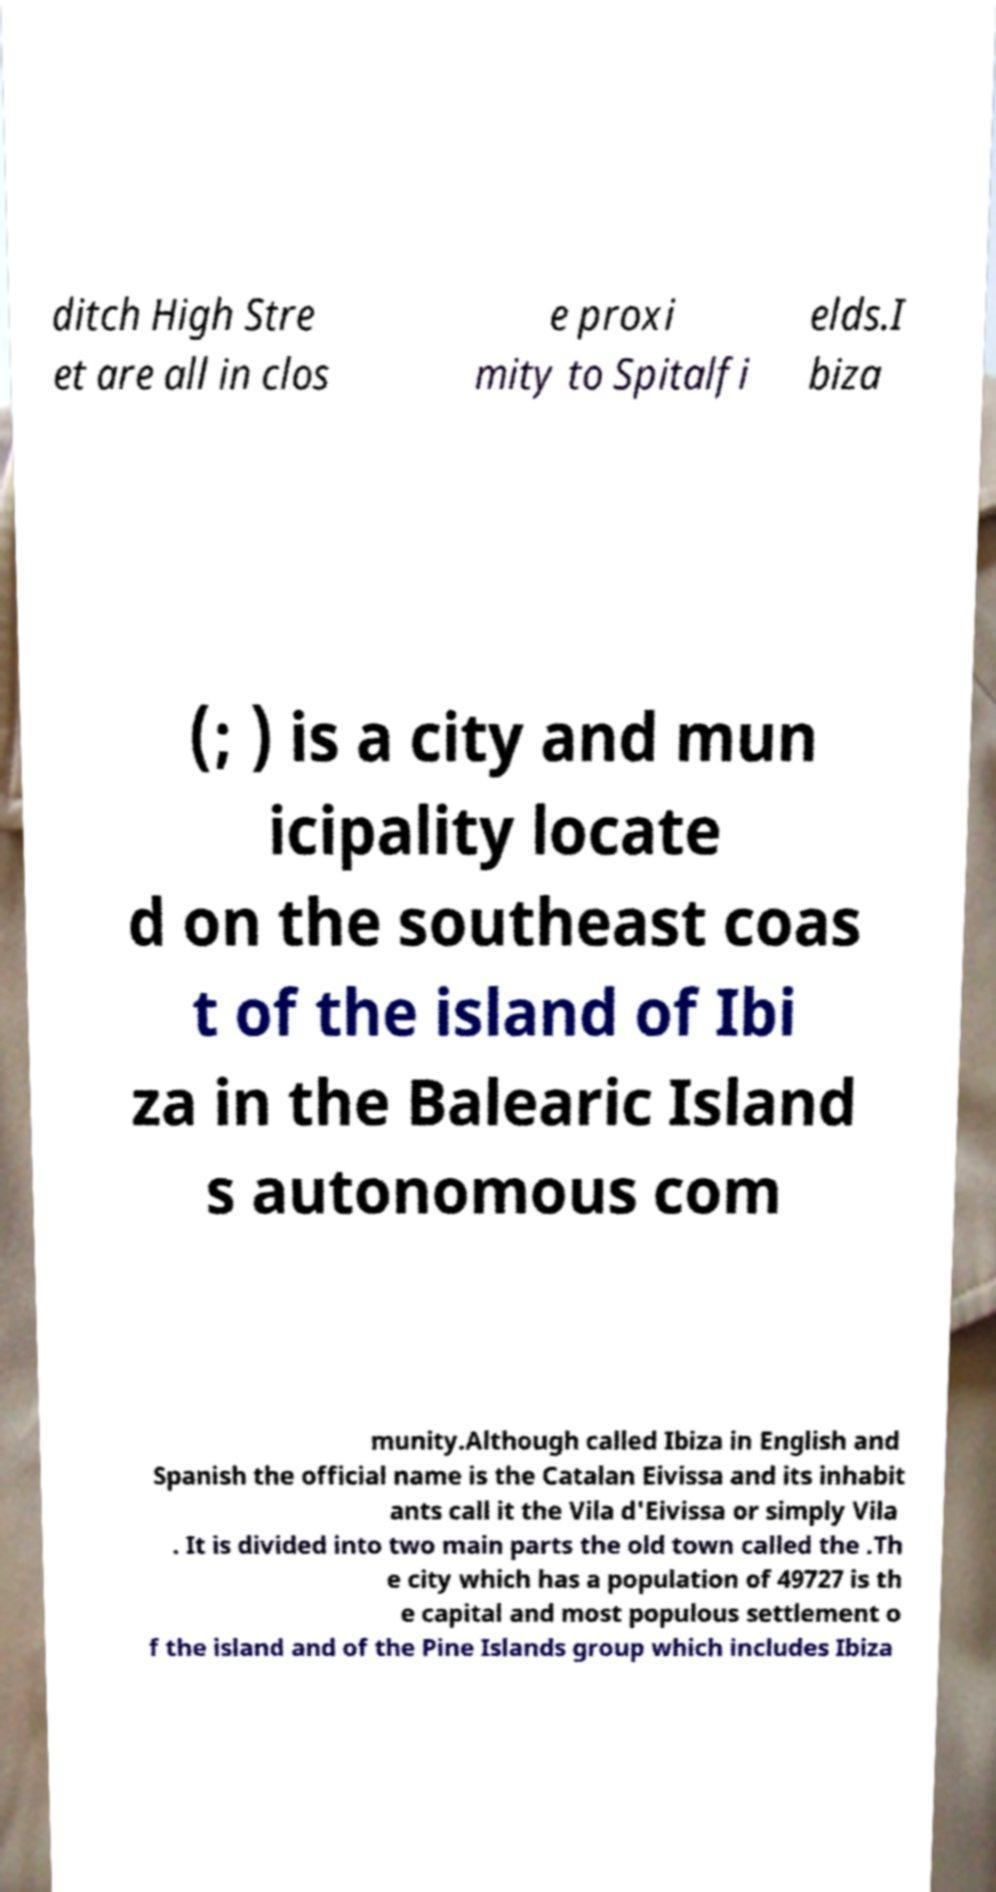Can you accurately transcribe the text from the provided image for me? ditch High Stre et are all in clos e proxi mity to Spitalfi elds.I biza (; ) is a city and mun icipality locate d on the southeast coas t of the island of Ibi za in the Balearic Island s autonomous com munity.Although called Ibiza in English and Spanish the official name is the Catalan Eivissa and its inhabit ants call it the Vila d'Eivissa or simply Vila . It is divided into two main parts the old town called the .Th e city which has a population of 49727 is th e capital and most populous settlement o f the island and of the Pine Islands group which includes Ibiza 